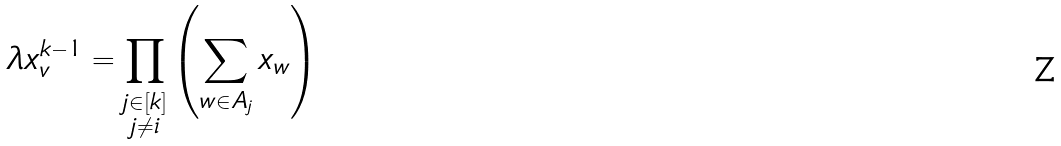Convert formula to latex. <formula><loc_0><loc_0><loc_500><loc_500>\lambda x _ { v } ^ { k - 1 } = \prod _ { \substack { j \in [ k ] \\ j \neq i } } \left ( \sum _ { w \in A _ { j } } x _ { w } \right )</formula> 